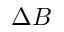Convert formula to latex. <formula><loc_0><loc_0><loc_500><loc_500>\Delta B</formula> 